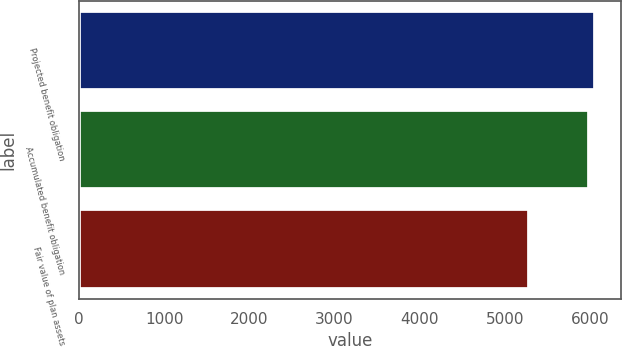Convert chart. <chart><loc_0><loc_0><loc_500><loc_500><bar_chart><fcel>Projected benefit obligation<fcel>Accumulated benefit obligation<fcel>Fair value of plan assets<nl><fcel>6056.8<fcel>5986<fcel>5282<nl></chart> 